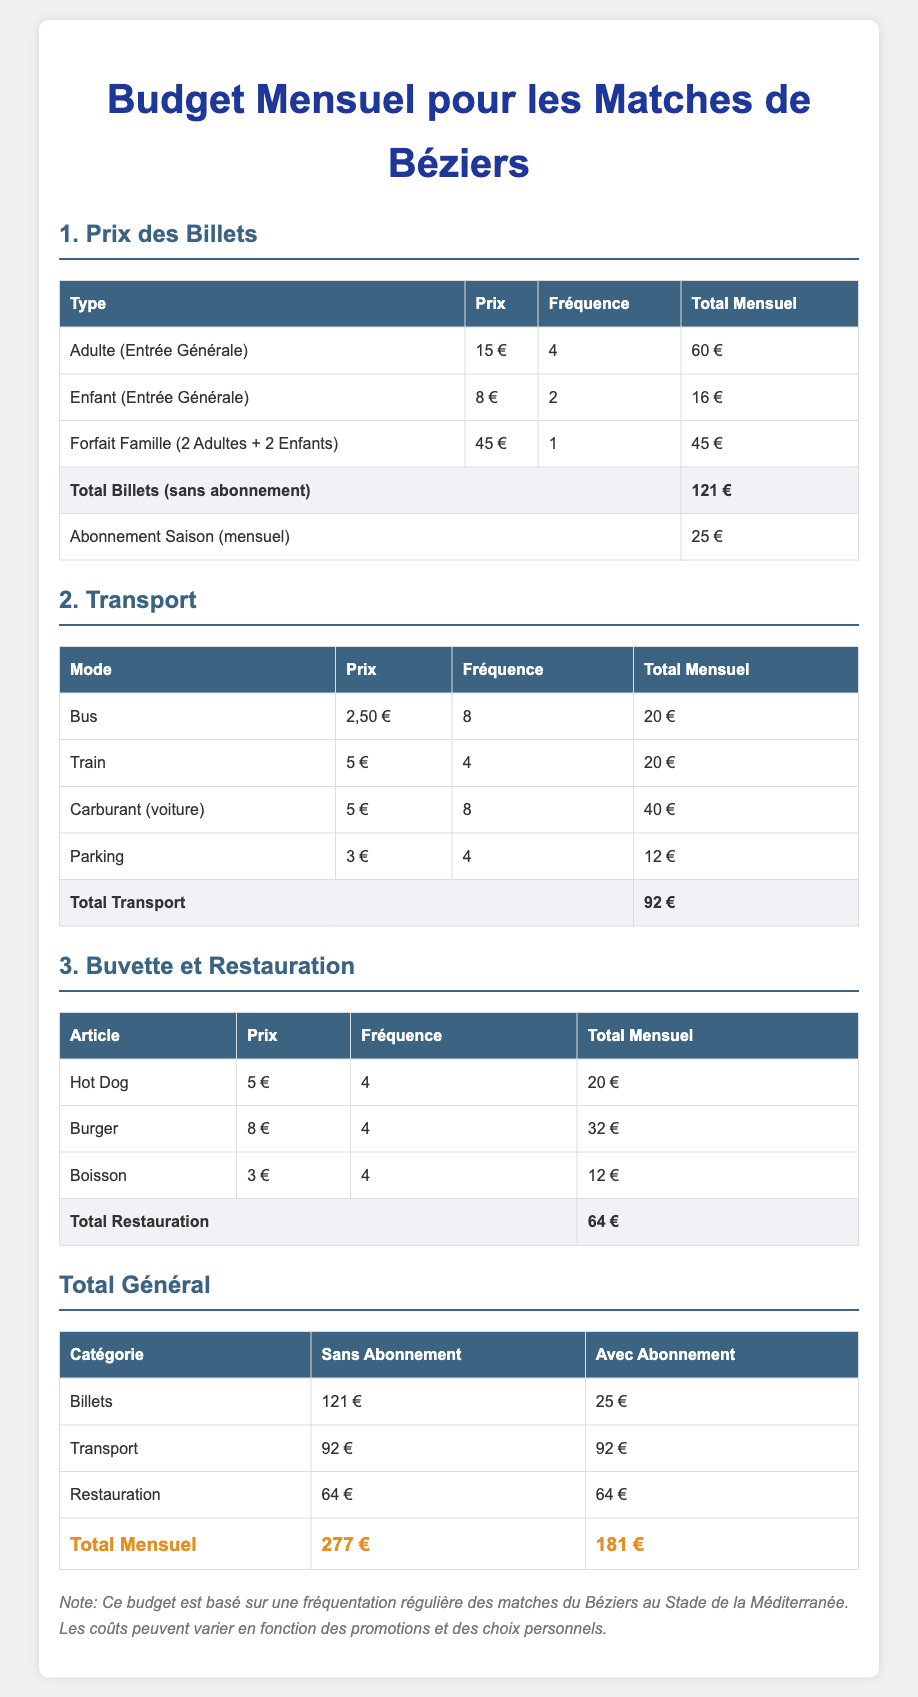Quel est le prix d'un billet adulte ? Le prix d'un billet adulte (entrée générale) est de 15 €.
Answer: 15 € Quel est le coût mensuel total pour le transport ? Le total des frais de transport est indiqué dans le tableau, qui montre 92 € pour le transport.
Answer: 92 € Combien coûte un abonnement saison ? Le prix de l'abonnement saison est de 25 € par mois.
Answer: 25 € Quel article de restauration coûte le plus cher ? En comparant les prix des articles de restauration, le burger est le plus cher à 8 €.
Answer: Burger Quel est le total général sans abonnement ? La somme des coûts sans abonnement est présentée à la fin du document et s'élève à 277 €.
Answer: 277 € Combien de fois par mois assiste-t-on à des matches avec l'abonnement ? Le tableau offre une vue d'ensemble, indiquant que l'abonnement permet d'assister à tous les matches du mois.
Answer: Illimité Quel est le total mensuel pour les billets avec un forfait famille ? Le forfait famille permet d'assister à un match pour 45 €, ce qui est inclus dans le total mensuel.
Answer: 45 € Combien de boissons sont achetées par mois ? Le tableau montre que 4 boissons sont achetées chaque mois, au prix unitaire de 3 €.
Answer: 4 Quel est le total de la restauration ? Le document indique que le total des coûts de restauration est de 64 €.
Answer: 64 € 